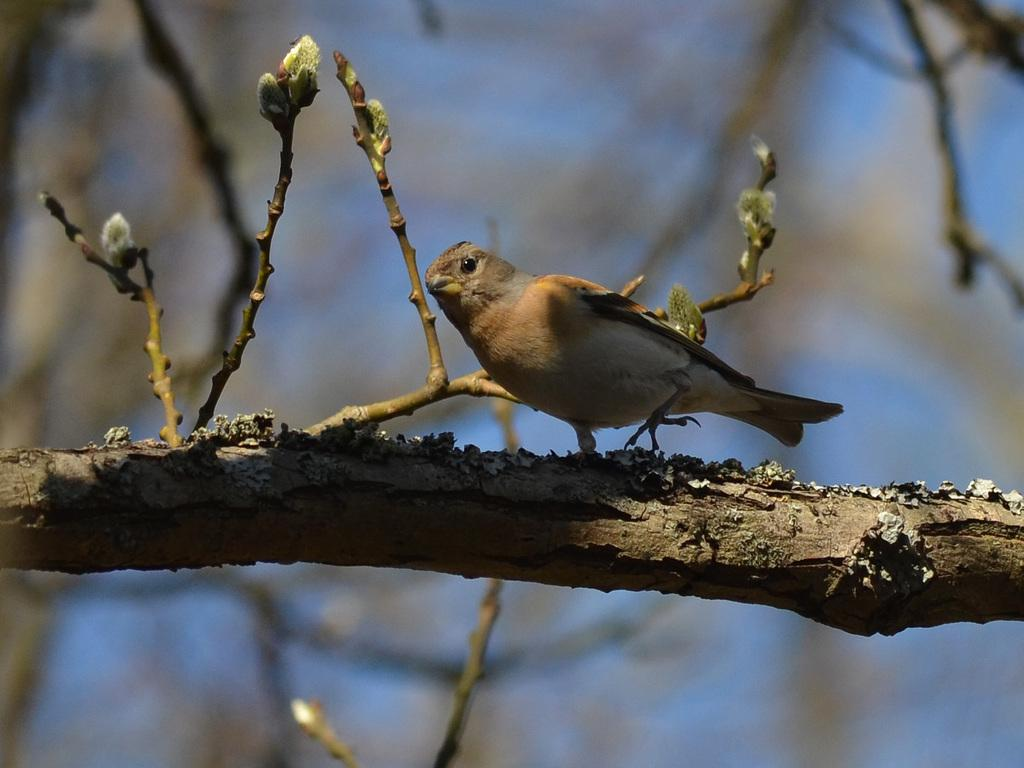What is located in the foreground of the image? There is a bird on a tree in the foreground of the image. What can be seen in the background of the image? There are trees and the sky visible in the background of the image. Where is the goldfish swimming in the image? There is no goldfish present in the image. What type of pleasure can be experienced by observing the bird in the image? The image does not convey any specific emotions or pleasures; it simply shows a bird on a tree. 